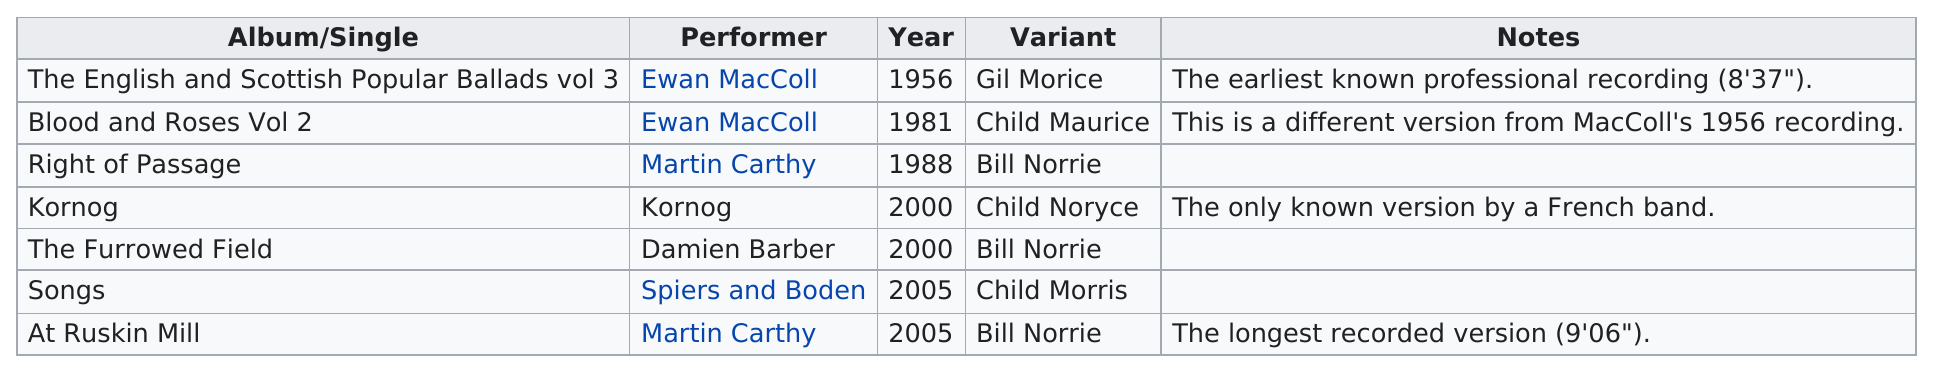Indicate a few pertinent items in this graphic. In the year 2000, a single or album was performed by the group Kornog. The first album released was in 1956. The performer with the same name as the album is Kornog. The album/single "The Furrowed Field" was released in the same year as the album/single "Kornog. The release of "The Furrowed Field" and "Songs of Love and Life" occurred five years apart. 